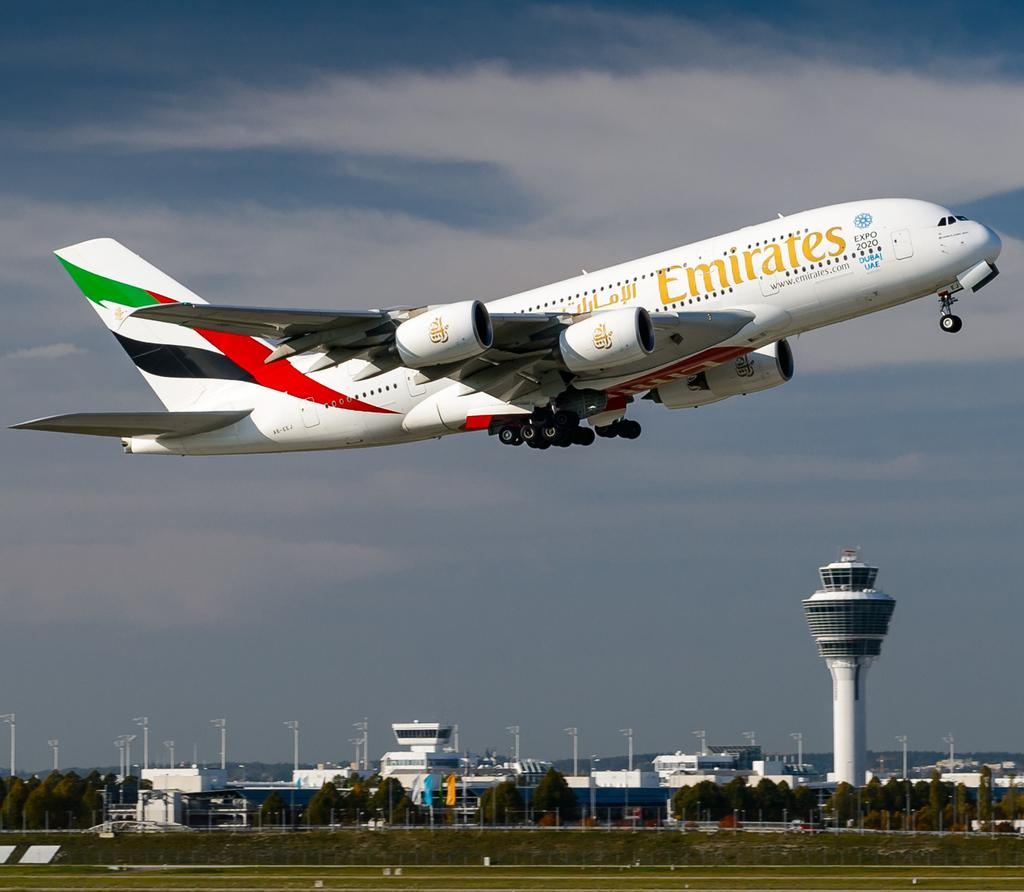Provide a one-sentence caption for the provided image. A plate from Emirates airlines is taking off and still close to the ground. 